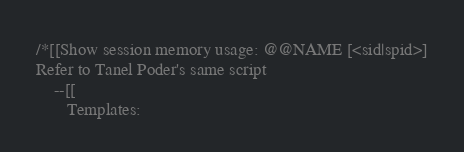Convert code to text. <code><loc_0><loc_0><loc_500><loc_500><_SQL_>/*[[Show session memory usage: @@NAME [<sid|spid>]
Refer to Tanel Poder's same script
    --[[
       Templates:</code> 